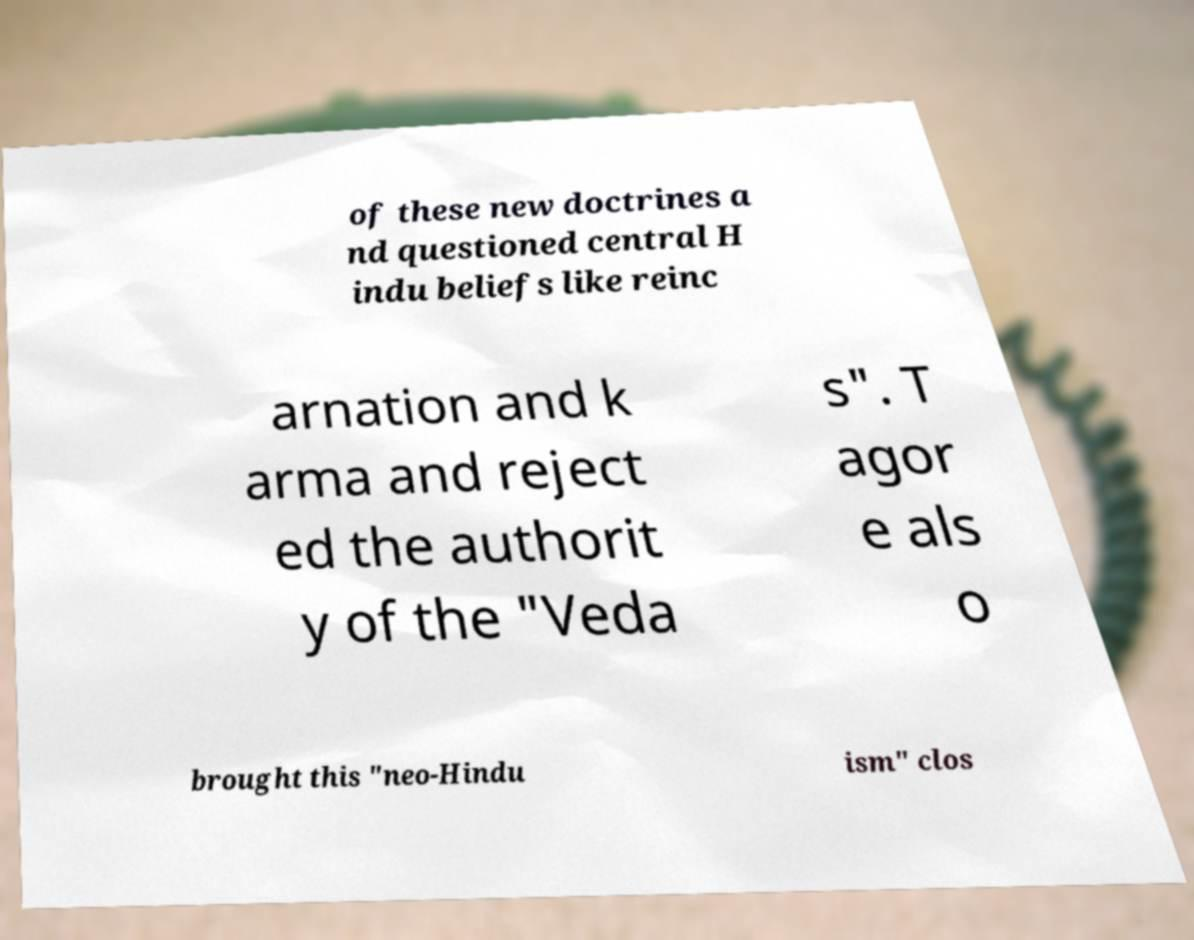Please identify and transcribe the text found in this image. of these new doctrines a nd questioned central H indu beliefs like reinc arnation and k arma and reject ed the authorit y of the "Veda s". T agor e als o brought this "neo-Hindu ism" clos 